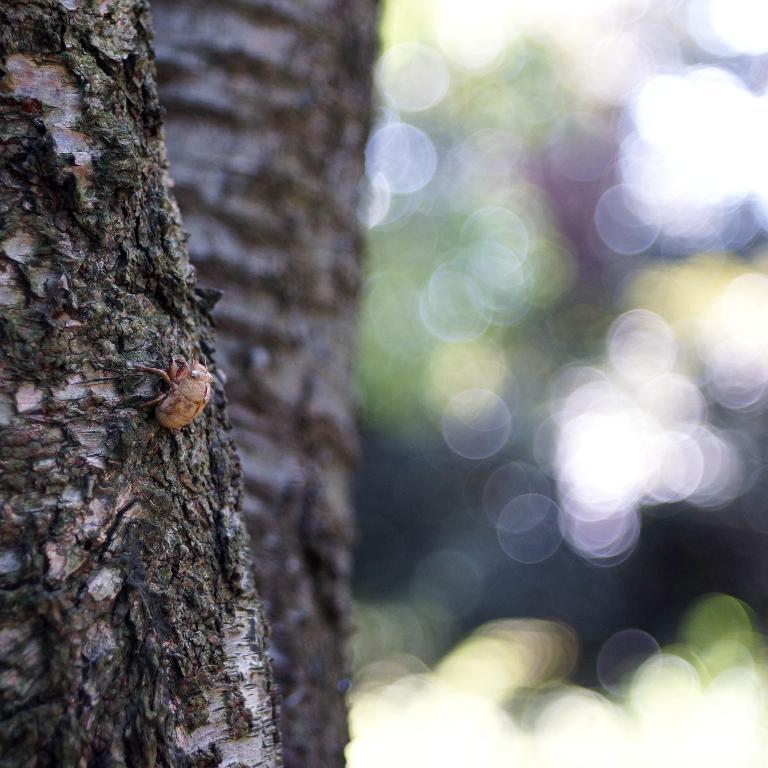What is located on the left side of the image? There is a tree on the left side of the image. Can you describe anything on the tree? Yes, there is an insect on the tree. How would you describe the overall appearance of the image? The background of the image is blurry. What type of pan can be seen hanging from the tree in the image? There is no pan present in the image; it features a tree with an insect on it. How does the acoustics of the insect's sound travel in the image? The image does not provide information about the acoustics of the insect's sound, as it only shows a visual representation of the tree and insect. 